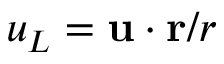Convert formula to latex. <formula><loc_0><loc_0><loc_500><loc_500>u _ { L } = { u } \cdot { r } / r</formula> 